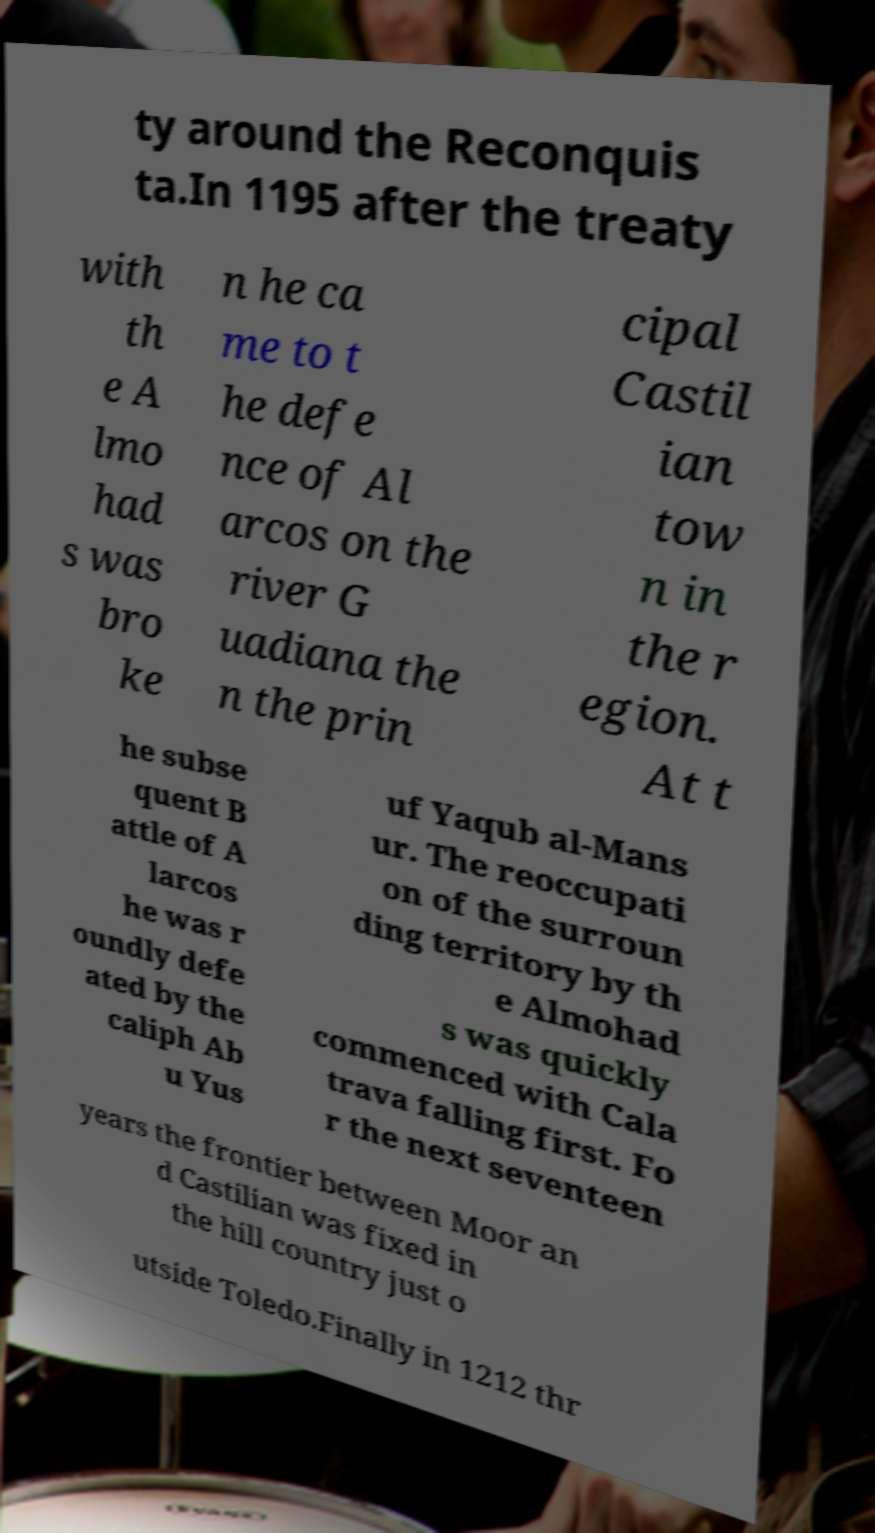I need the written content from this picture converted into text. Can you do that? ty around the Reconquis ta.In 1195 after the treaty with th e A lmo had s was bro ke n he ca me to t he defe nce of Al arcos on the river G uadiana the n the prin cipal Castil ian tow n in the r egion. At t he subse quent B attle of A larcos he was r oundly defe ated by the caliph Ab u Yus uf Yaqub al-Mans ur. The reoccupati on of the surroun ding territory by th e Almohad s was quickly commenced with Cala trava falling first. Fo r the next seventeen years the frontier between Moor an d Castilian was fixed in the hill country just o utside Toledo.Finally in 1212 thr 